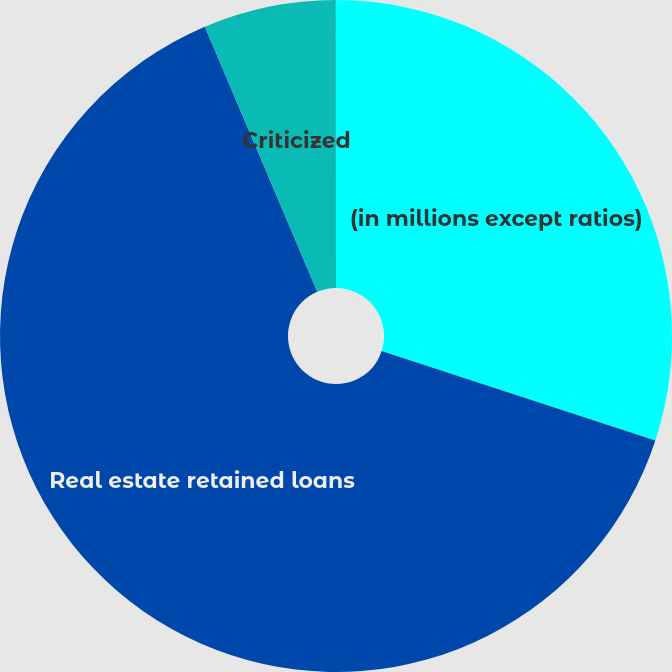Convert chart to OTSL. <chart><loc_0><loc_0><loc_500><loc_500><pie_chart><fcel>(in millions except ratios)<fcel>Real estate retained loans<fcel>Criticized<fcel>of criticized to total real<nl><fcel>30.03%<fcel>63.58%<fcel>6.37%<fcel>0.01%<nl></chart> 